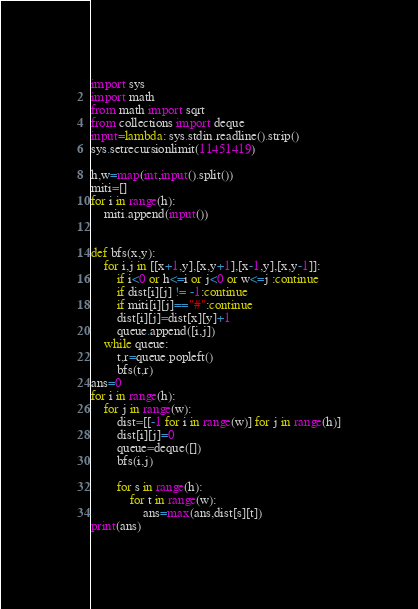Convert code to text. <code><loc_0><loc_0><loc_500><loc_500><_Python_>import sys
import math
from math import sqrt
from collections import deque
input=lambda: sys.stdin.readline().strip()
sys.setrecursionlimit(11451419)

h,w=map(int,input().split())
miti=[]
for i in range(h):
    miti.append(input())
    

def bfs(x,y):
    for i,j in [[x+1,y],[x,y+1],[x-1,y],[x,y-1]]:
        if i<0 or h<=i or j<0 or w<=j :continue
        if dist[i][j] != -1:continue
        if miti[i][j]=="#":continue
        dist[i][j]=dist[x][y]+1
        queue.append([i,j])
    while queue:
        t,r=queue.popleft()
        bfs(t,r)
ans=0
for i in range(h):
    for j in range(w):
        dist=[[-1 for i in range(w)] for j in range(h)]
        dist[i][j]=0
        queue=deque([])
        bfs(i,j)
        
        for s in range(h):
            for t in range(w):
                ans=max(ans,dist[s][t])
print(ans)</code> 